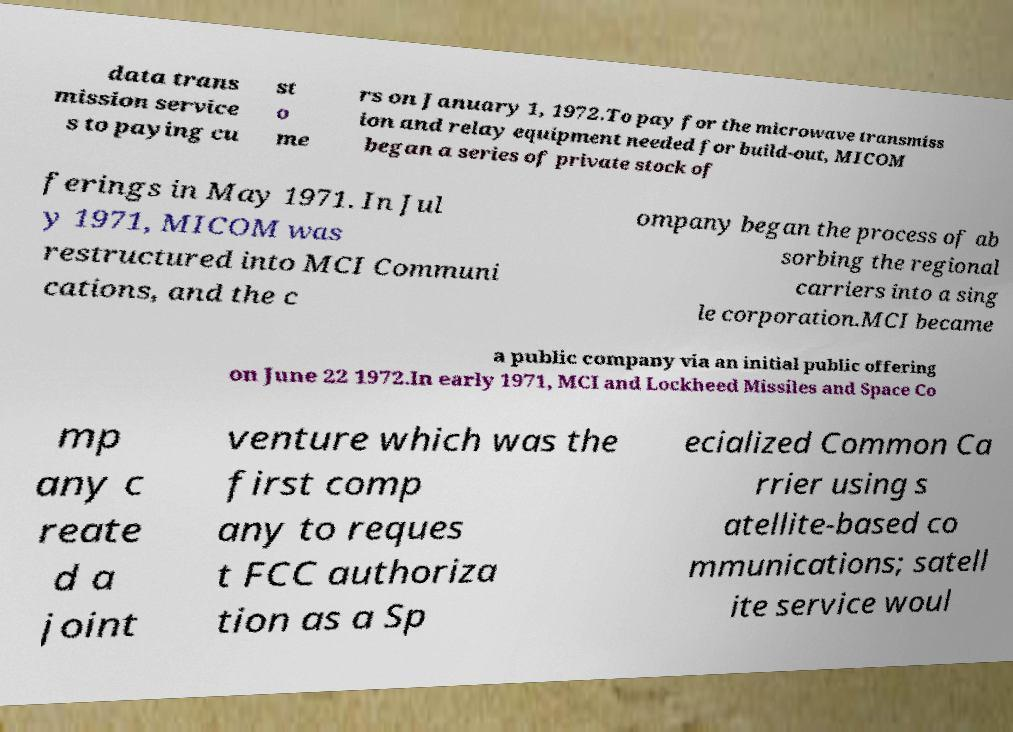For documentation purposes, I need the text within this image transcribed. Could you provide that? data trans mission service s to paying cu st o me rs on January 1, 1972.To pay for the microwave transmiss ion and relay equipment needed for build-out, MICOM began a series of private stock of ferings in May 1971. In Jul y 1971, MICOM was restructured into MCI Communi cations, and the c ompany began the process of ab sorbing the regional carriers into a sing le corporation.MCI became a public company via an initial public offering on June 22 1972.In early 1971, MCI and Lockheed Missiles and Space Co mp any c reate d a joint venture which was the first comp any to reques t FCC authoriza tion as a Sp ecialized Common Ca rrier using s atellite-based co mmunications; satell ite service woul 